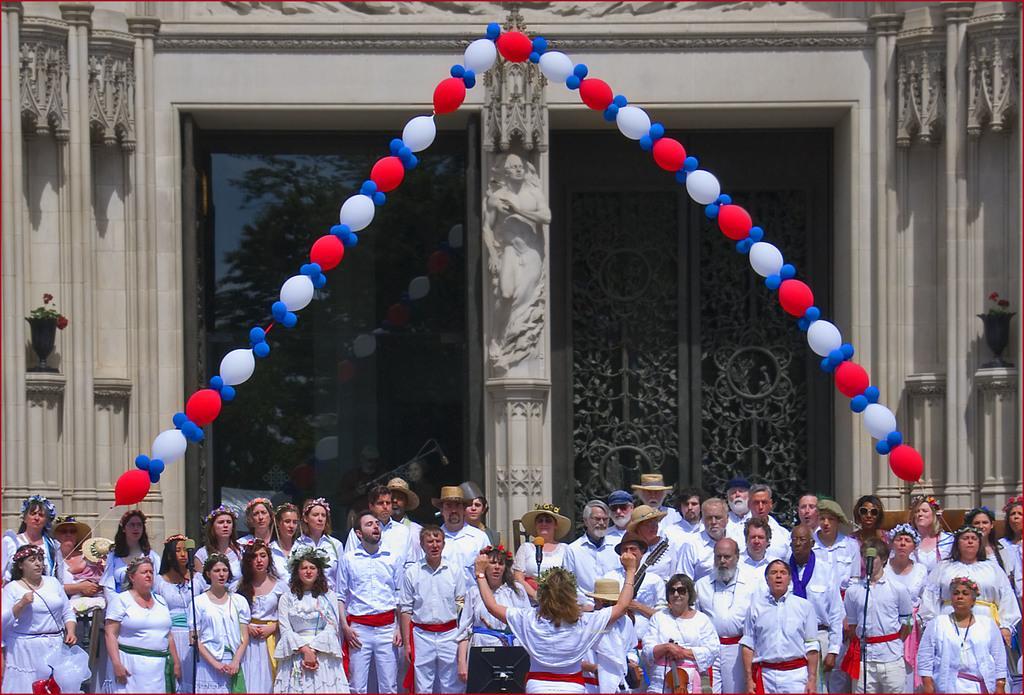How would you summarize this image in a sentence or two? At the bottom of this image, there are persons in the white color dresses, standing. Some of them are wearing caps. Above them, there are balloons arranged like an arch. In the background, there is a sculpture on a pillar of a building which is having a glass and iron doors. 